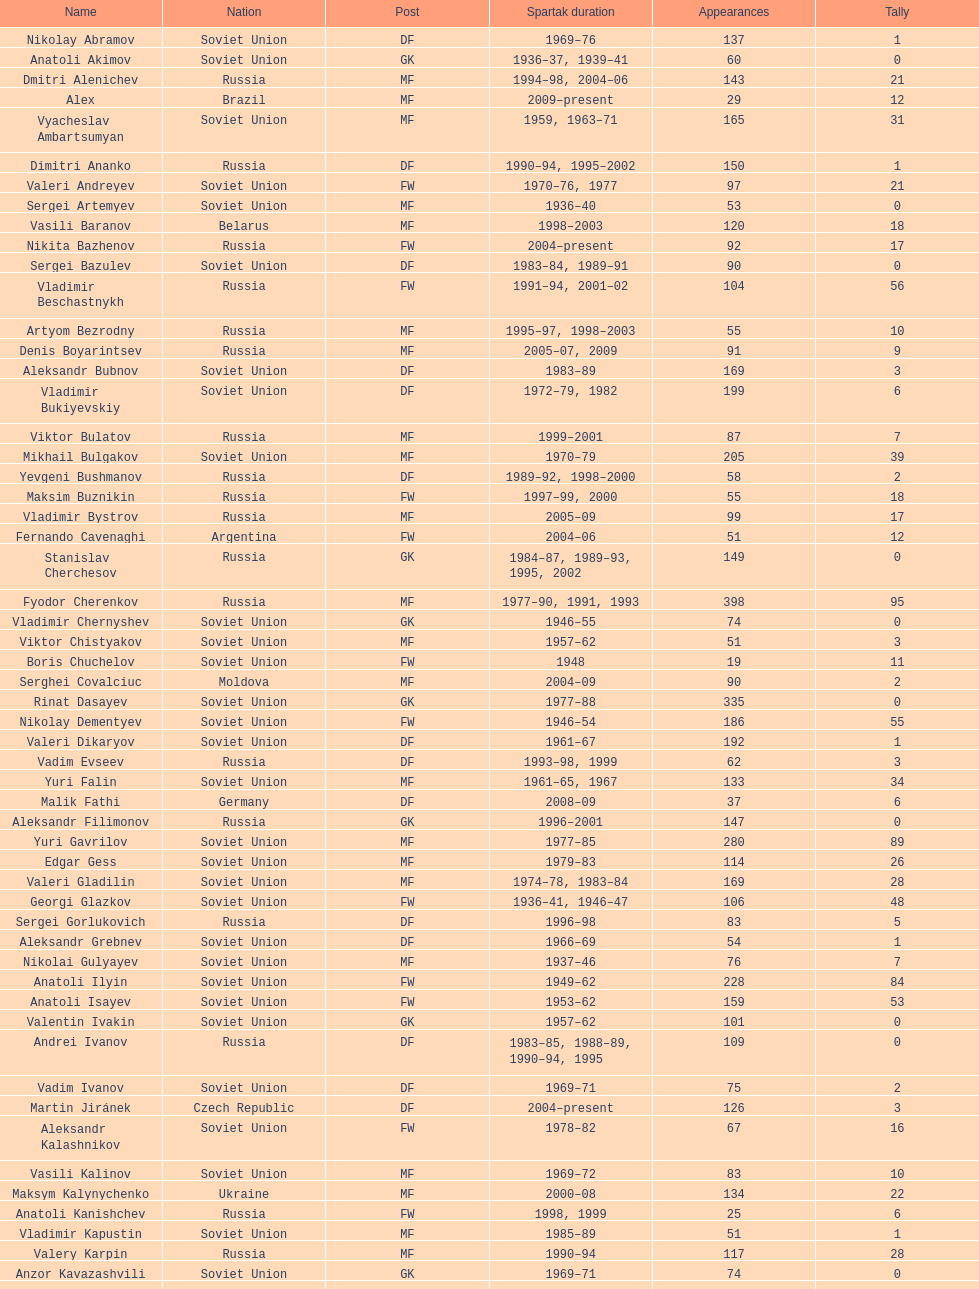Which player has the most appearances with the club? Fyodor Cherenkov. 